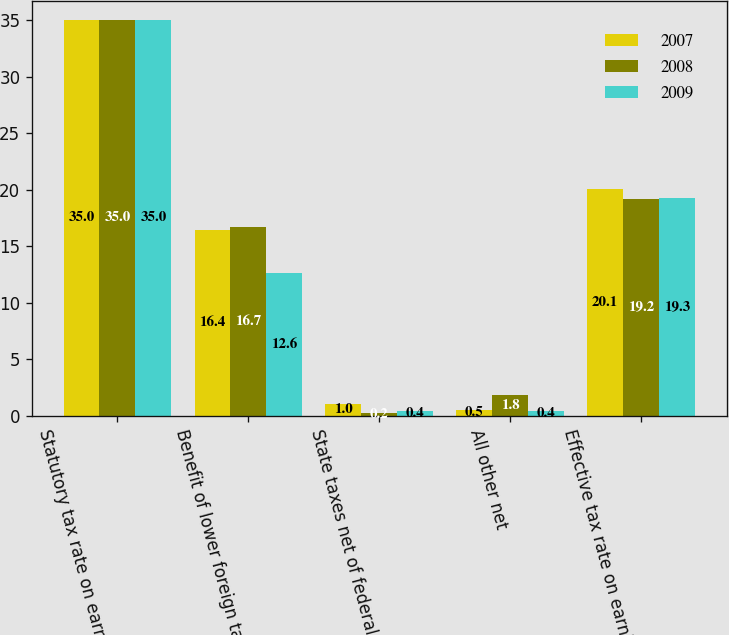<chart> <loc_0><loc_0><loc_500><loc_500><stacked_bar_chart><ecel><fcel>Statutory tax rate on earnings<fcel>Benefit of lower foreign tax<fcel>State taxes net of federal<fcel>All other net<fcel>Effective tax rate on earnings<nl><fcel>2007<fcel>35<fcel>16.4<fcel>1<fcel>0.5<fcel>20.1<nl><fcel>2008<fcel>35<fcel>16.7<fcel>0.2<fcel>1.8<fcel>19.2<nl><fcel>2009<fcel>35<fcel>12.6<fcel>0.4<fcel>0.4<fcel>19.3<nl></chart> 